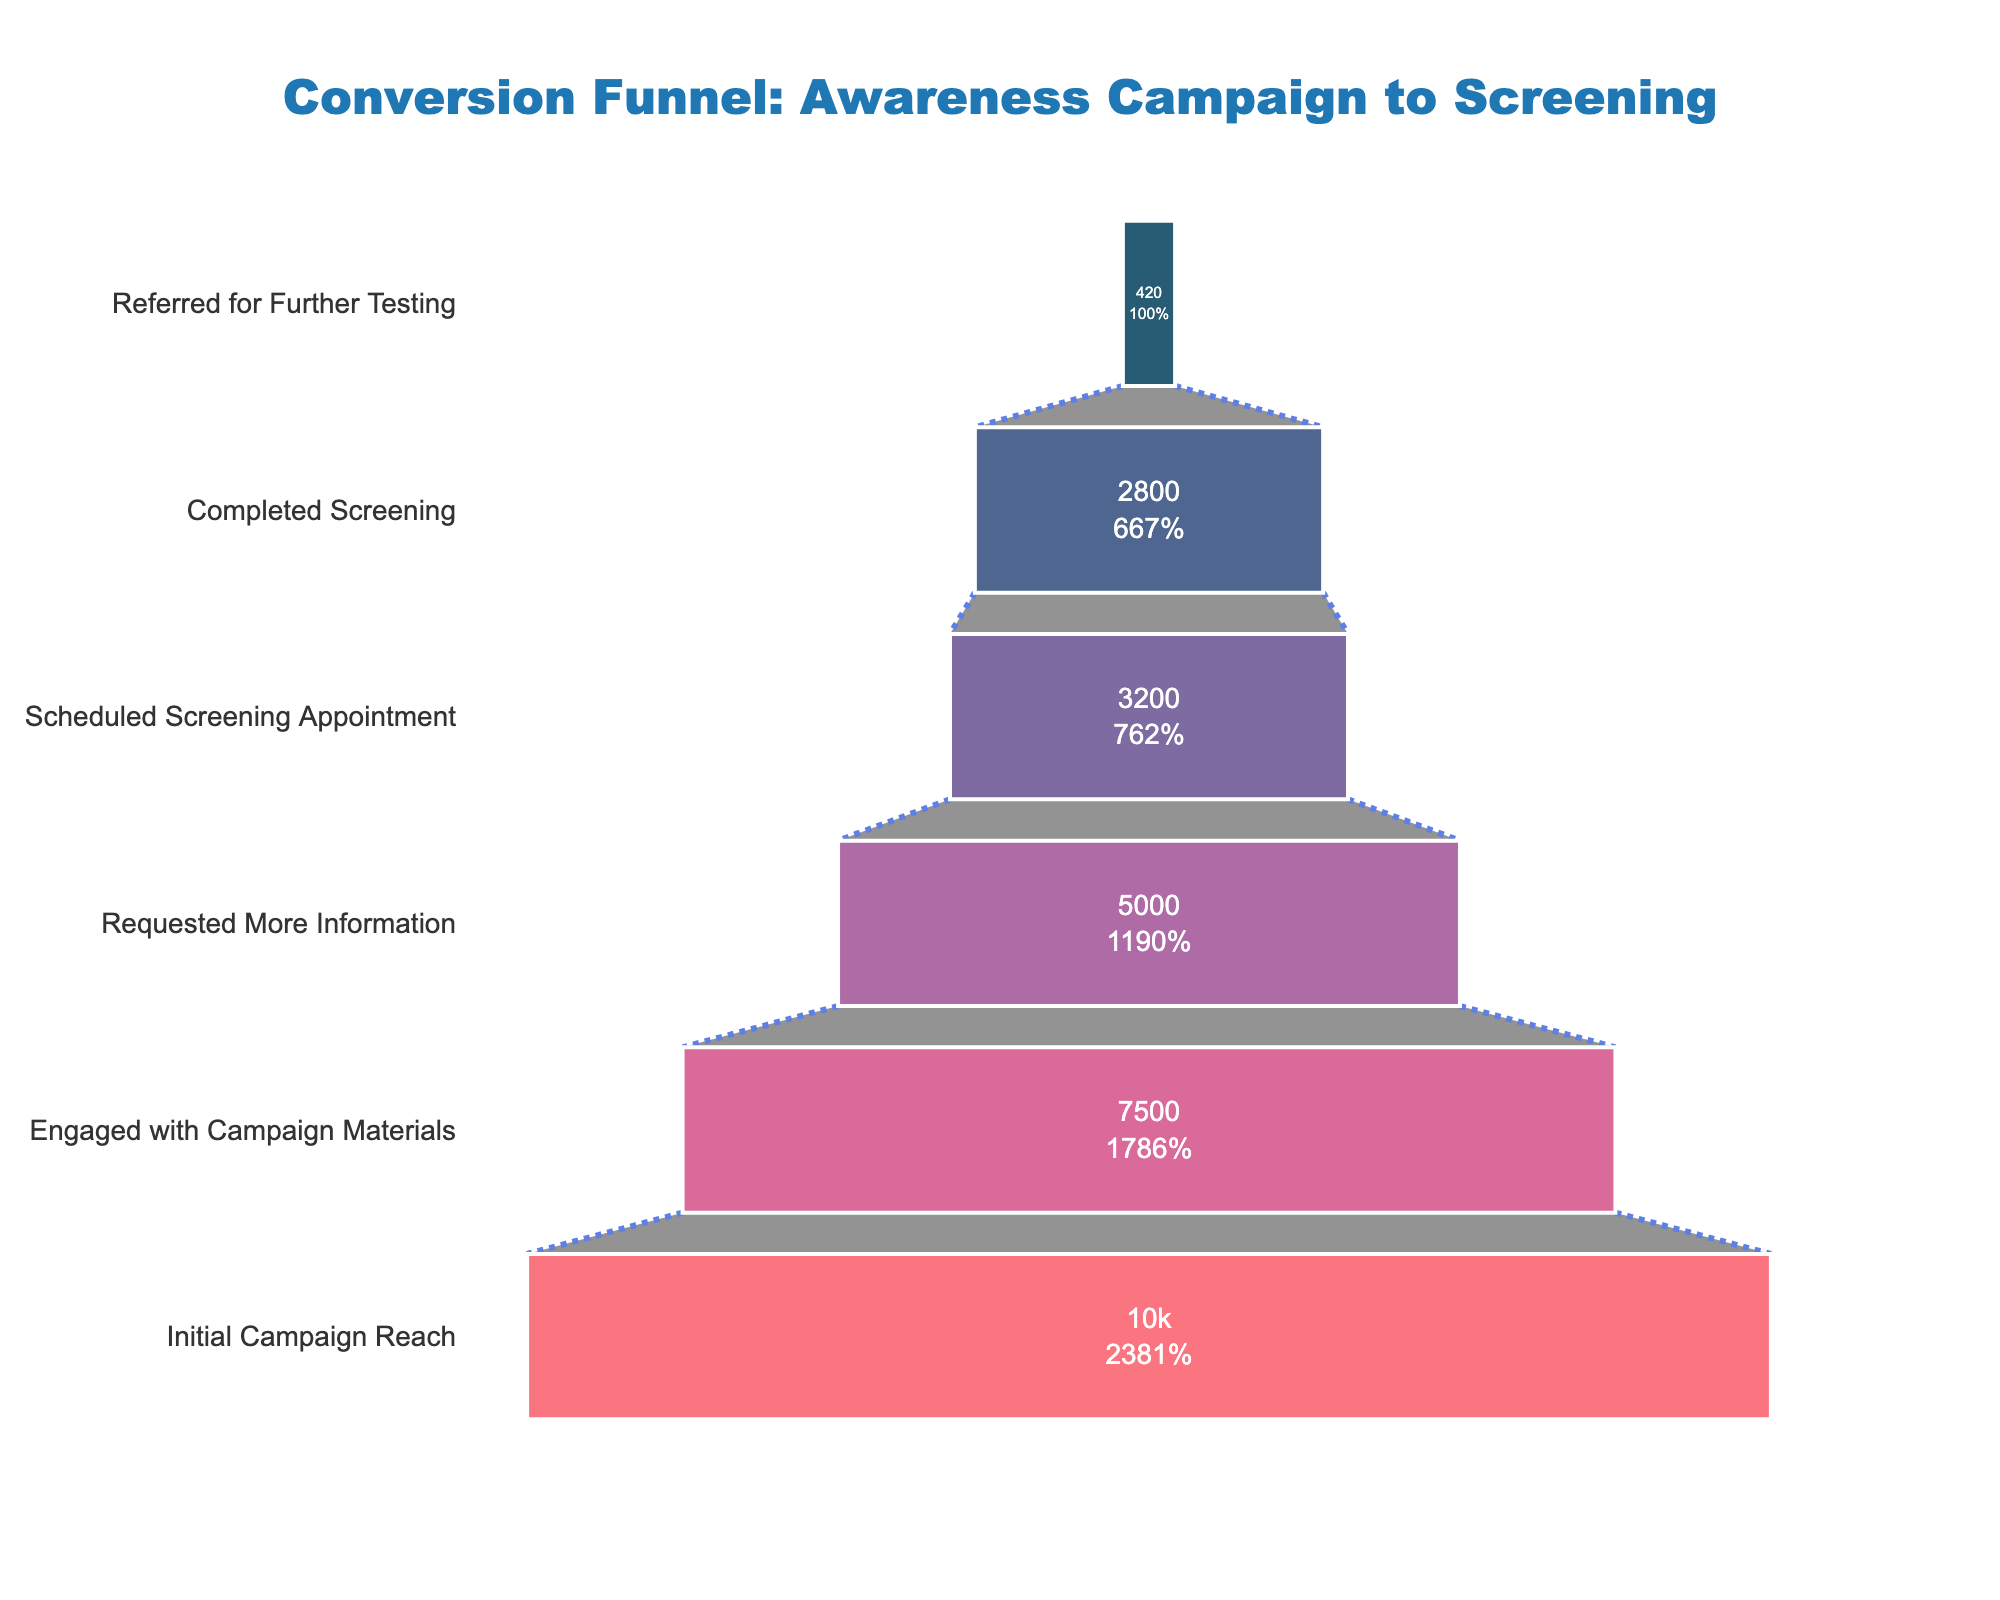What's the total number of participants who completed the screening? Look for the bar corresponding to 'Completed Screening' and note the number presented inside the bar.
Answer: 2800 How many participants scheduled a screening appointment? Search for the bar titled 'Scheduled Screening Appointment' and read the number of participants.
Answer: 3200 What percentage of the initial campaign reach completed the screening? Take the number of participants who completed the screening (2800) and divide it by the initial campaign reach (10000), then multiply by 100 to get the percentage.
Answer: 28% What is the difference in the number of participants between those who scheduled a screening appointment and those who completed it? Subtract the number of participants who completed the screening (2800) from those who scheduled an appointment (3200).
Answer: 400 Which stage had the biggest drop in the number of participants? Compare the decline between each consecutive stage. The largest drop occurs between 'Requested More Information' (5000) and 'Scheduled Screening Appointment' (3200).
Answer: From requesting more information to scheduling an appointment How many participants did not complete the screening after scheduling an appointment? Subtract the number of participants who completed the screening (2800) from those who scheduled an appointment (3200).
Answer: 400 What percentage of participants engaged with campaign materials relative to the initial campaign reach? Divide the number of participants who engaged with campaign materials (7500) by the initial campaign reach (10000) and multiply by 100.
Answer: 75% Compare the number of participants in 'Requested More Information' and 'Engaged with Campaign Materials'. How many participants dropped out at this stage? Subtract the number in 'Requested More Information' (5000) from 'Engaged with Campaign Materials' (7500).
Answer: 2500 What percentage of participants who completed the screening were referred for further testing? Divide the number of referred participants (420) by the number who completed the screening (2800) and multiply by 100.
Answer: 15% Between which stages is the smallest drop in participant numbers observed? Find the stage pair where the difference between participant numbers is the smallest. Comparing all stages, the smallest drop is between 'Completed Screening' (2800) and 'Referred for Further Testing' (420).
Answer: From completing screening to referral for further testing 